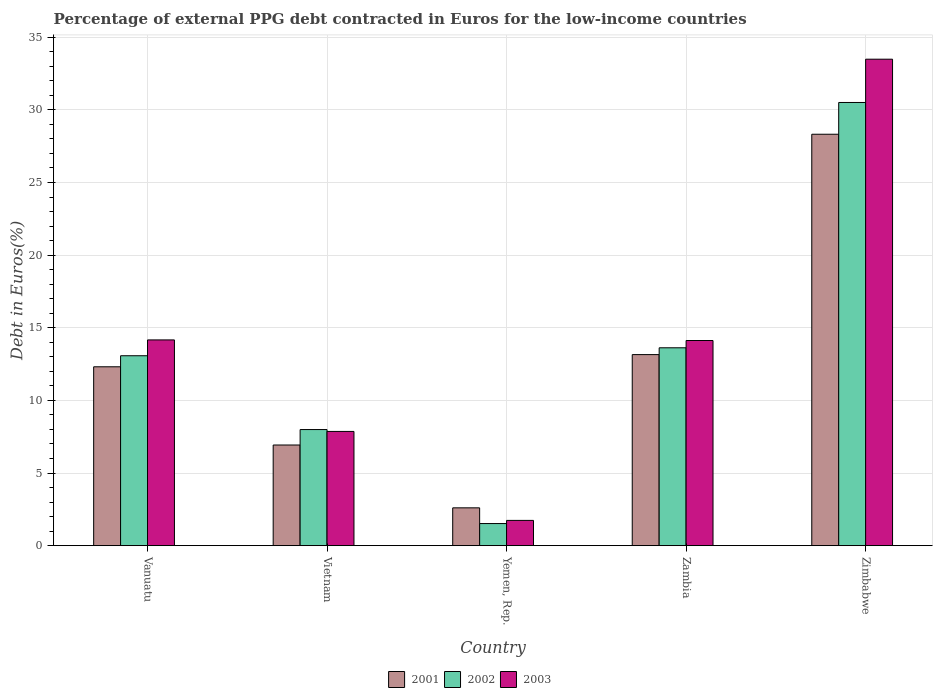Are the number of bars on each tick of the X-axis equal?
Your answer should be compact. Yes. How many bars are there on the 1st tick from the left?
Offer a terse response. 3. What is the label of the 1st group of bars from the left?
Offer a terse response. Vanuatu. In how many cases, is the number of bars for a given country not equal to the number of legend labels?
Give a very brief answer. 0. What is the percentage of external PPG debt contracted in Euros in 2002 in Yemen, Rep.?
Keep it short and to the point. 1.52. Across all countries, what is the maximum percentage of external PPG debt contracted in Euros in 2001?
Offer a terse response. 28.32. Across all countries, what is the minimum percentage of external PPG debt contracted in Euros in 2001?
Ensure brevity in your answer.  2.6. In which country was the percentage of external PPG debt contracted in Euros in 2001 maximum?
Your answer should be very brief. Zimbabwe. In which country was the percentage of external PPG debt contracted in Euros in 2001 minimum?
Keep it short and to the point. Yemen, Rep. What is the total percentage of external PPG debt contracted in Euros in 2003 in the graph?
Make the answer very short. 71.38. What is the difference between the percentage of external PPG debt contracted in Euros in 2002 in Vanuatu and that in Yemen, Rep.?
Your response must be concise. 11.55. What is the difference between the percentage of external PPG debt contracted in Euros in 2002 in Yemen, Rep. and the percentage of external PPG debt contracted in Euros in 2001 in Vanuatu?
Make the answer very short. -10.79. What is the average percentage of external PPG debt contracted in Euros in 2002 per country?
Offer a very short reply. 13.35. What is the difference between the percentage of external PPG debt contracted in Euros of/in 2002 and percentage of external PPG debt contracted in Euros of/in 2003 in Yemen, Rep.?
Give a very brief answer. -0.22. In how many countries, is the percentage of external PPG debt contracted in Euros in 2002 greater than 11 %?
Provide a short and direct response. 3. What is the ratio of the percentage of external PPG debt contracted in Euros in 2003 in Yemen, Rep. to that in Zimbabwe?
Your answer should be compact. 0.05. Is the difference between the percentage of external PPG debt contracted in Euros in 2002 in Vanuatu and Yemen, Rep. greater than the difference between the percentage of external PPG debt contracted in Euros in 2003 in Vanuatu and Yemen, Rep.?
Give a very brief answer. No. What is the difference between the highest and the second highest percentage of external PPG debt contracted in Euros in 2003?
Offer a very short reply. 19.32. What is the difference between the highest and the lowest percentage of external PPG debt contracted in Euros in 2001?
Your answer should be very brief. 25.72. In how many countries, is the percentage of external PPG debt contracted in Euros in 2001 greater than the average percentage of external PPG debt contracted in Euros in 2001 taken over all countries?
Ensure brevity in your answer.  2. What does the 3rd bar from the left in Zambia represents?
Provide a succinct answer. 2003. What does the 2nd bar from the right in Zambia represents?
Your answer should be very brief. 2002. Is it the case that in every country, the sum of the percentage of external PPG debt contracted in Euros in 2002 and percentage of external PPG debt contracted in Euros in 2003 is greater than the percentage of external PPG debt contracted in Euros in 2001?
Your answer should be very brief. Yes. Are the values on the major ticks of Y-axis written in scientific E-notation?
Ensure brevity in your answer.  No. What is the title of the graph?
Give a very brief answer. Percentage of external PPG debt contracted in Euros for the low-income countries. Does "1998" appear as one of the legend labels in the graph?
Keep it short and to the point. No. What is the label or title of the Y-axis?
Your answer should be very brief. Debt in Euros(%). What is the Debt in Euros(%) of 2001 in Vanuatu?
Your answer should be compact. 12.32. What is the Debt in Euros(%) in 2002 in Vanuatu?
Give a very brief answer. 13.08. What is the Debt in Euros(%) in 2003 in Vanuatu?
Your answer should be very brief. 14.17. What is the Debt in Euros(%) of 2001 in Vietnam?
Your response must be concise. 6.93. What is the Debt in Euros(%) in 2002 in Vietnam?
Your response must be concise. 7.99. What is the Debt in Euros(%) in 2003 in Vietnam?
Make the answer very short. 7.87. What is the Debt in Euros(%) of 2001 in Yemen, Rep.?
Your answer should be compact. 2.6. What is the Debt in Euros(%) of 2002 in Yemen, Rep.?
Your response must be concise. 1.52. What is the Debt in Euros(%) of 2003 in Yemen, Rep.?
Provide a short and direct response. 1.74. What is the Debt in Euros(%) of 2001 in Zambia?
Provide a succinct answer. 13.15. What is the Debt in Euros(%) of 2002 in Zambia?
Ensure brevity in your answer.  13.62. What is the Debt in Euros(%) of 2003 in Zambia?
Give a very brief answer. 14.12. What is the Debt in Euros(%) in 2001 in Zimbabwe?
Your answer should be compact. 28.32. What is the Debt in Euros(%) in 2002 in Zimbabwe?
Keep it short and to the point. 30.51. What is the Debt in Euros(%) in 2003 in Zimbabwe?
Keep it short and to the point. 33.49. Across all countries, what is the maximum Debt in Euros(%) in 2001?
Provide a short and direct response. 28.32. Across all countries, what is the maximum Debt in Euros(%) of 2002?
Your response must be concise. 30.51. Across all countries, what is the maximum Debt in Euros(%) of 2003?
Your response must be concise. 33.49. Across all countries, what is the minimum Debt in Euros(%) of 2001?
Offer a very short reply. 2.6. Across all countries, what is the minimum Debt in Euros(%) in 2002?
Make the answer very short. 1.52. Across all countries, what is the minimum Debt in Euros(%) in 2003?
Offer a terse response. 1.74. What is the total Debt in Euros(%) of 2001 in the graph?
Give a very brief answer. 63.33. What is the total Debt in Euros(%) in 2002 in the graph?
Your answer should be very brief. 66.73. What is the total Debt in Euros(%) in 2003 in the graph?
Offer a very short reply. 71.39. What is the difference between the Debt in Euros(%) in 2001 in Vanuatu and that in Vietnam?
Your answer should be compact. 5.39. What is the difference between the Debt in Euros(%) in 2002 in Vanuatu and that in Vietnam?
Offer a very short reply. 5.08. What is the difference between the Debt in Euros(%) of 2003 in Vanuatu and that in Vietnam?
Offer a terse response. 6.3. What is the difference between the Debt in Euros(%) in 2001 in Vanuatu and that in Yemen, Rep.?
Ensure brevity in your answer.  9.71. What is the difference between the Debt in Euros(%) in 2002 in Vanuatu and that in Yemen, Rep.?
Offer a terse response. 11.55. What is the difference between the Debt in Euros(%) in 2003 in Vanuatu and that in Yemen, Rep.?
Provide a short and direct response. 12.42. What is the difference between the Debt in Euros(%) in 2001 in Vanuatu and that in Zambia?
Your answer should be compact. -0.84. What is the difference between the Debt in Euros(%) of 2002 in Vanuatu and that in Zambia?
Give a very brief answer. -0.55. What is the difference between the Debt in Euros(%) in 2003 in Vanuatu and that in Zambia?
Your answer should be very brief. 0.04. What is the difference between the Debt in Euros(%) in 2001 in Vanuatu and that in Zimbabwe?
Your answer should be compact. -16.01. What is the difference between the Debt in Euros(%) in 2002 in Vanuatu and that in Zimbabwe?
Your answer should be very brief. -17.43. What is the difference between the Debt in Euros(%) of 2003 in Vanuatu and that in Zimbabwe?
Offer a very short reply. -19.32. What is the difference between the Debt in Euros(%) in 2001 in Vietnam and that in Yemen, Rep.?
Make the answer very short. 4.33. What is the difference between the Debt in Euros(%) of 2002 in Vietnam and that in Yemen, Rep.?
Ensure brevity in your answer.  6.47. What is the difference between the Debt in Euros(%) in 2003 in Vietnam and that in Yemen, Rep.?
Offer a terse response. 6.12. What is the difference between the Debt in Euros(%) in 2001 in Vietnam and that in Zambia?
Offer a terse response. -6.22. What is the difference between the Debt in Euros(%) of 2002 in Vietnam and that in Zambia?
Keep it short and to the point. -5.63. What is the difference between the Debt in Euros(%) in 2003 in Vietnam and that in Zambia?
Offer a terse response. -6.26. What is the difference between the Debt in Euros(%) of 2001 in Vietnam and that in Zimbabwe?
Provide a short and direct response. -21.39. What is the difference between the Debt in Euros(%) in 2002 in Vietnam and that in Zimbabwe?
Your response must be concise. -22.52. What is the difference between the Debt in Euros(%) in 2003 in Vietnam and that in Zimbabwe?
Offer a very short reply. -25.62. What is the difference between the Debt in Euros(%) of 2001 in Yemen, Rep. and that in Zambia?
Your answer should be compact. -10.55. What is the difference between the Debt in Euros(%) in 2002 in Yemen, Rep. and that in Zambia?
Provide a succinct answer. -12.1. What is the difference between the Debt in Euros(%) of 2003 in Yemen, Rep. and that in Zambia?
Your answer should be very brief. -12.38. What is the difference between the Debt in Euros(%) of 2001 in Yemen, Rep. and that in Zimbabwe?
Ensure brevity in your answer.  -25.72. What is the difference between the Debt in Euros(%) of 2002 in Yemen, Rep. and that in Zimbabwe?
Your answer should be very brief. -28.99. What is the difference between the Debt in Euros(%) in 2003 in Yemen, Rep. and that in Zimbabwe?
Provide a short and direct response. -31.75. What is the difference between the Debt in Euros(%) of 2001 in Zambia and that in Zimbabwe?
Make the answer very short. -15.17. What is the difference between the Debt in Euros(%) in 2002 in Zambia and that in Zimbabwe?
Offer a very short reply. -16.89. What is the difference between the Debt in Euros(%) of 2003 in Zambia and that in Zimbabwe?
Give a very brief answer. -19.36. What is the difference between the Debt in Euros(%) of 2001 in Vanuatu and the Debt in Euros(%) of 2002 in Vietnam?
Offer a terse response. 4.32. What is the difference between the Debt in Euros(%) of 2001 in Vanuatu and the Debt in Euros(%) of 2003 in Vietnam?
Offer a terse response. 4.45. What is the difference between the Debt in Euros(%) in 2002 in Vanuatu and the Debt in Euros(%) in 2003 in Vietnam?
Your answer should be very brief. 5.21. What is the difference between the Debt in Euros(%) of 2001 in Vanuatu and the Debt in Euros(%) of 2002 in Yemen, Rep.?
Your answer should be compact. 10.79. What is the difference between the Debt in Euros(%) of 2001 in Vanuatu and the Debt in Euros(%) of 2003 in Yemen, Rep.?
Give a very brief answer. 10.57. What is the difference between the Debt in Euros(%) in 2002 in Vanuatu and the Debt in Euros(%) in 2003 in Yemen, Rep.?
Give a very brief answer. 11.33. What is the difference between the Debt in Euros(%) of 2001 in Vanuatu and the Debt in Euros(%) of 2002 in Zambia?
Offer a terse response. -1.31. What is the difference between the Debt in Euros(%) in 2001 in Vanuatu and the Debt in Euros(%) in 2003 in Zambia?
Offer a terse response. -1.81. What is the difference between the Debt in Euros(%) of 2002 in Vanuatu and the Debt in Euros(%) of 2003 in Zambia?
Make the answer very short. -1.05. What is the difference between the Debt in Euros(%) of 2001 in Vanuatu and the Debt in Euros(%) of 2002 in Zimbabwe?
Your response must be concise. -18.19. What is the difference between the Debt in Euros(%) of 2001 in Vanuatu and the Debt in Euros(%) of 2003 in Zimbabwe?
Keep it short and to the point. -21.17. What is the difference between the Debt in Euros(%) in 2002 in Vanuatu and the Debt in Euros(%) in 2003 in Zimbabwe?
Make the answer very short. -20.41. What is the difference between the Debt in Euros(%) in 2001 in Vietnam and the Debt in Euros(%) in 2002 in Yemen, Rep.?
Your answer should be compact. 5.41. What is the difference between the Debt in Euros(%) in 2001 in Vietnam and the Debt in Euros(%) in 2003 in Yemen, Rep.?
Provide a short and direct response. 5.19. What is the difference between the Debt in Euros(%) in 2002 in Vietnam and the Debt in Euros(%) in 2003 in Yemen, Rep.?
Offer a terse response. 6.25. What is the difference between the Debt in Euros(%) of 2001 in Vietnam and the Debt in Euros(%) of 2002 in Zambia?
Ensure brevity in your answer.  -6.69. What is the difference between the Debt in Euros(%) in 2001 in Vietnam and the Debt in Euros(%) in 2003 in Zambia?
Offer a terse response. -7.19. What is the difference between the Debt in Euros(%) in 2002 in Vietnam and the Debt in Euros(%) in 2003 in Zambia?
Provide a succinct answer. -6.13. What is the difference between the Debt in Euros(%) in 2001 in Vietnam and the Debt in Euros(%) in 2002 in Zimbabwe?
Your answer should be compact. -23.58. What is the difference between the Debt in Euros(%) in 2001 in Vietnam and the Debt in Euros(%) in 2003 in Zimbabwe?
Make the answer very short. -26.56. What is the difference between the Debt in Euros(%) in 2002 in Vietnam and the Debt in Euros(%) in 2003 in Zimbabwe?
Offer a very short reply. -25.5. What is the difference between the Debt in Euros(%) of 2001 in Yemen, Rep. and the Debt in Euros(%) of 2002 in Zambia?
Provide a succinct answer. -11.02. What is the difference between the Debt in Euros(%) of 2001 in Yemen, Rep. and the Debt in Euros(%) of 2003 in Zambia?
Offer a terse response. -11.52. What is the difference between the Debt in Euros(%) of 2002 in Yemen, Rep. and the Debt in Euros(%) of 2003 in Zambia?
Keep it short and to the point. -12.6. What is the difference between the Debt in Euros(%) in 2001 in Yemen, Rep. and the Debt in Euros(%) in 2002 in Zimbabwe?
Your response must be concise. -27.91. What is the difference between the Debt in Euros(%) of 2001 in Yemen, Rep. and the Debt in Euros(%) of 2003 in Zimbabwe?
Ensure brevity in your answer.  -30.88. What is the difference between the Debt in Euros(%) of 2002 in Yemen, Rep. and the Debt in Euros(%) of 2003 in Zimbabwe?
Your response must be concise. -31.97. What is the difference between the Debt in Euros(%) in 2001 in Zambia and the Debt in Euros(%) in 2002 in Zimbabwe?
Your answer should be compact. -17.36. What is the difference between the Debt in Euros(%) in 2001 in Zambia and the Debt in Euros(%) in 2003 in Zimbabwe?
Make the answer very short. -20.33. What is the difference between the Debt in Euros(%) of 2002 in Zambia and the Debt in Euros(%) of 2003 in Zimbabwe?
Your answer should be very brief. -19.87. What is the average Debt in Euros(%) in 2001 per country?
Give a very brief answer. 12.67. What is the average Debt in Euros(%) of 2002 per country?
Provide a succinct answer. 13.35. What is the average Debt in Euros(%) of 2003 per country?
Provide a short and direct response. 14.28. What is the difference between the Debt in Euros(%) in 2001 and Debt in Euros(%) in 2002 in Vanuatu?
Give a very brief answer. -0.76. What is the difference between the Debt in Euros(%) of 2001 and Debt in Euros(%) of 2003 in Vanuatu?
Offer a very short reply. -1.85. What is the difference between the Debt in Euros(%) of 2002 and Debt in Euros(%) of 2003 in Vanuatu?
Keep it short and to the point. -1.09. What is the difference between the Debt in Euros(%) of 2001 and Debt in Euros(%) of 2002 in Vietnam?
Keep it short and to the point. -1.06. What is the difference between the Debt in Euros(%) of 2001 and Debt in Euros(%) of 2003 in Vietnam?
Your answer should be very brief. -0.94. What is the difference between the Debt in Euros(%) of 2002 and Debt in Euros(%) of 2003 in Vietnam?
Provide a short and direct response. 0.13. What is the difference between the Debt in Euros(%) in 2001 and Debt in Euros(%) in 2002 in Yemen, Rep.?
Provide a succinct answer. 1.08. What is the difference between the Debt in Euros(%) of 2001 and Debt in Euros(%) of 2003 in Yemen, Rep.?
Your response must be concise. 0.86. What is the difference between the Debt in Euros(%) in 2002 and Debt in Euros(%) in 2003 in Yemen, Rep.?
Give a very brief answer. -0.22. What is the difference between the Debt in Euros(%) of 2001 and Debt in Euros(%) of 2002 in Zambia?
Offer a terse response. -0.47. What is the difference between the Debt in Euros(%) of 2001 and Debt in Euros(%) of 2003 in Zambia?
Your answer should be very brief. -0.97. What is the difference between the Debt in Euros(%) of 2002 and Debt in Euros(%) of 2003 in Zambia?
Your answer should be very brief. -0.5. What is the difference between the Debt in Euros(%) of 2001 and Debt in Euros(%) of 2002 in Zimbabwe?
Offer a very short reply. -2.19. What is the difference between the Debt in Euros(%) in 2001 and Debt in Euros(%) in 2003 in Zimbabwe?
Provide a succinct answer. -5.17. What is the difference between the Debt in Euros(%) of 2002 and Debt in Euros(%) of 2003 in Zimbabwe?
Your response must be concise. -2.98. What is the ratio of the Debt in Euros(%) of 2001 in Vanuatu to that in Vietnam?
Ensure brevity in your answer.  1.78. What is the ratio of the Debt in Euros(%) in 2002 in Vanuatu to that in Vietnam?
Keep it short and to the point. 1.64. What is the ratio of the Debt in Euros(%) in 2003 in Vanuatu to that in Vietnam?
Give a very brief answer. 1.8. What is the ratio of the Debt in Euros(%) of 2001 in Vanuatu to that in Yemen, Rep.?
Ensure brevity in your answer.  4.73. What is the ratio of the Debt in Euros(%) of 2002 in Vanuatu to that in Yemen, Rep.?
Make the answer very short. 8.59. What is the ratio of the Debt in Euros(%) in 2003 in Vanuatu to that in Yemen, Rep.?
Keep it short and to the point. 8.14. What is the ratio of the Debt in Euros(%) of 2001 in Vanuatu to that in Zambia?
Ensure brevity in your answer.  0.94. What is the ratio of the Debt in Euros(%) in 2002 in Vanuatu to that in Zambia?
Your answer should be compact. 0.96. What is the ratio of the Debt in Euros(%) in 2003 in Vanuatu to that in Zambia?
Offer a very short reply. 1. What is the ratio of the Debt in Euros(%) of 2001 in Vanuatu to that in Zimbabwe?
Your response must be concise. 0.43. What is the ratio of the Debt in Euros(%) in 2002 in Vanuatu to that in Zimbabwe?
Give a very brief answer. 0.43. What is the ratio of the Debt in Euros(%) in 2003 in Vanuatu to that in Zimbabwe?
Your answer should be compact. 0.42. What is the ratio of the Debt in Euros(%) of 2001 in Vietnam to that in Yemen, Rep.?
Provide a succinct answer. 2.66. What is the ratio of the Debt in Euros(%) in 2002 in Vietnam to that in Yemen, Rep.?
Your answer should be very brief. 5.25. What is the ratio of the Debt in Euros(%) in 2003 in Vietnam to that in Yemen, Rep.?
Offer a terse response. 4.52. What is the ratio of the Debt in Euros(%) in 2001 in Vietnam to that in Zambia?
Your answer should be very brief. 0.53. What is the ratio of the Debt in Euros(%) in 2002 in Vietnam to that in Zambia?
Your response must be concise. 0.59. What is the ratio of the Debt in Euros(%) in 2003 in Vietnam to that in Zambia?
Offer a terse response. 0.56. What is the ratio of the Debt in Euros(%) in 2001 in Vietnam to that in Zimbabwe?
Offer a terse response. 0.24. What is the ratio of the Debt in Euros(%) of 2002 in Vietnam to that in Zimbabwe?
Offer a very short reply. 0.26. What is the ratio of the Debt in Euros(%) of 2003 in Vietnam to that in Zimbabwe?
Keep it short and to the point. 0.23. What is the ratio of the Debt in Euros(%) of 2001 in Yemen, Rep. to that in Zambia?
Make the answer very short. 0.2. What is the ratio of the Debt in Euros(%) in 2002 in Yemen, Rep. to that in Zambia?
Your answer should be compact. 0.11. What is the ratio of the Debt in Euros(%) in 2003 in Yemen, Rep. to that in Zambia?
Make the answer very short. 0.12. What is the ratio of the Debt in Euros(%) in 2001 in Yemen, Rep. to that in Zimbabwe?
Provide a succinct answer. 0.09. What is the ratio of the Debt in Euros(%) of 2002 in Yemen, Rep. to that in Zimbabwe?
Keep it short and to the point. 0.05. What is the ratio of the Debt in Euros(%) of 2003 in Yemen, Rep. to that in Zimbabwe?
Give a very brief answer. 0.05. What is the ratio of the Debt in Euros(%) of 2001 in Zambia to that in Zimbabwe?
Offer a terse response. 0.46. What is the ratio of the Debt in Euros(%) of 2002 in Zambia to that in Zimbabwe?
Your response must be concise. 0.45. What is the ratio of the Debt in Euros(%) of 2003 in Zambia to that in Zimbabwe?
Offer a very short reply. 0.42. What is the difference between the highest and the second highest Debt in Euros(%) in 2001?
Keep it short and to the point. 15.17. What is the difference between the highest and the second highest Debt in Euros(%) of 2002?
Make the answer very short. 16.89. What is the difference between the highest and the second highest Debt in Euros(%) in 2003?
Ensure brevity in your answer.  19.32. What is the difference between the highest and the lowest Debt in Euros(%) of 2001?
Give a very brief answer. 25.72. What is the difference between the highest and the lowest Debt in Euros(%) in 2002?
Your answer should be compact. 28.99. What is the difference between the highest and the lowest Debt in Euros(%) in 2003?
Your answer should be compact. 31.75. 